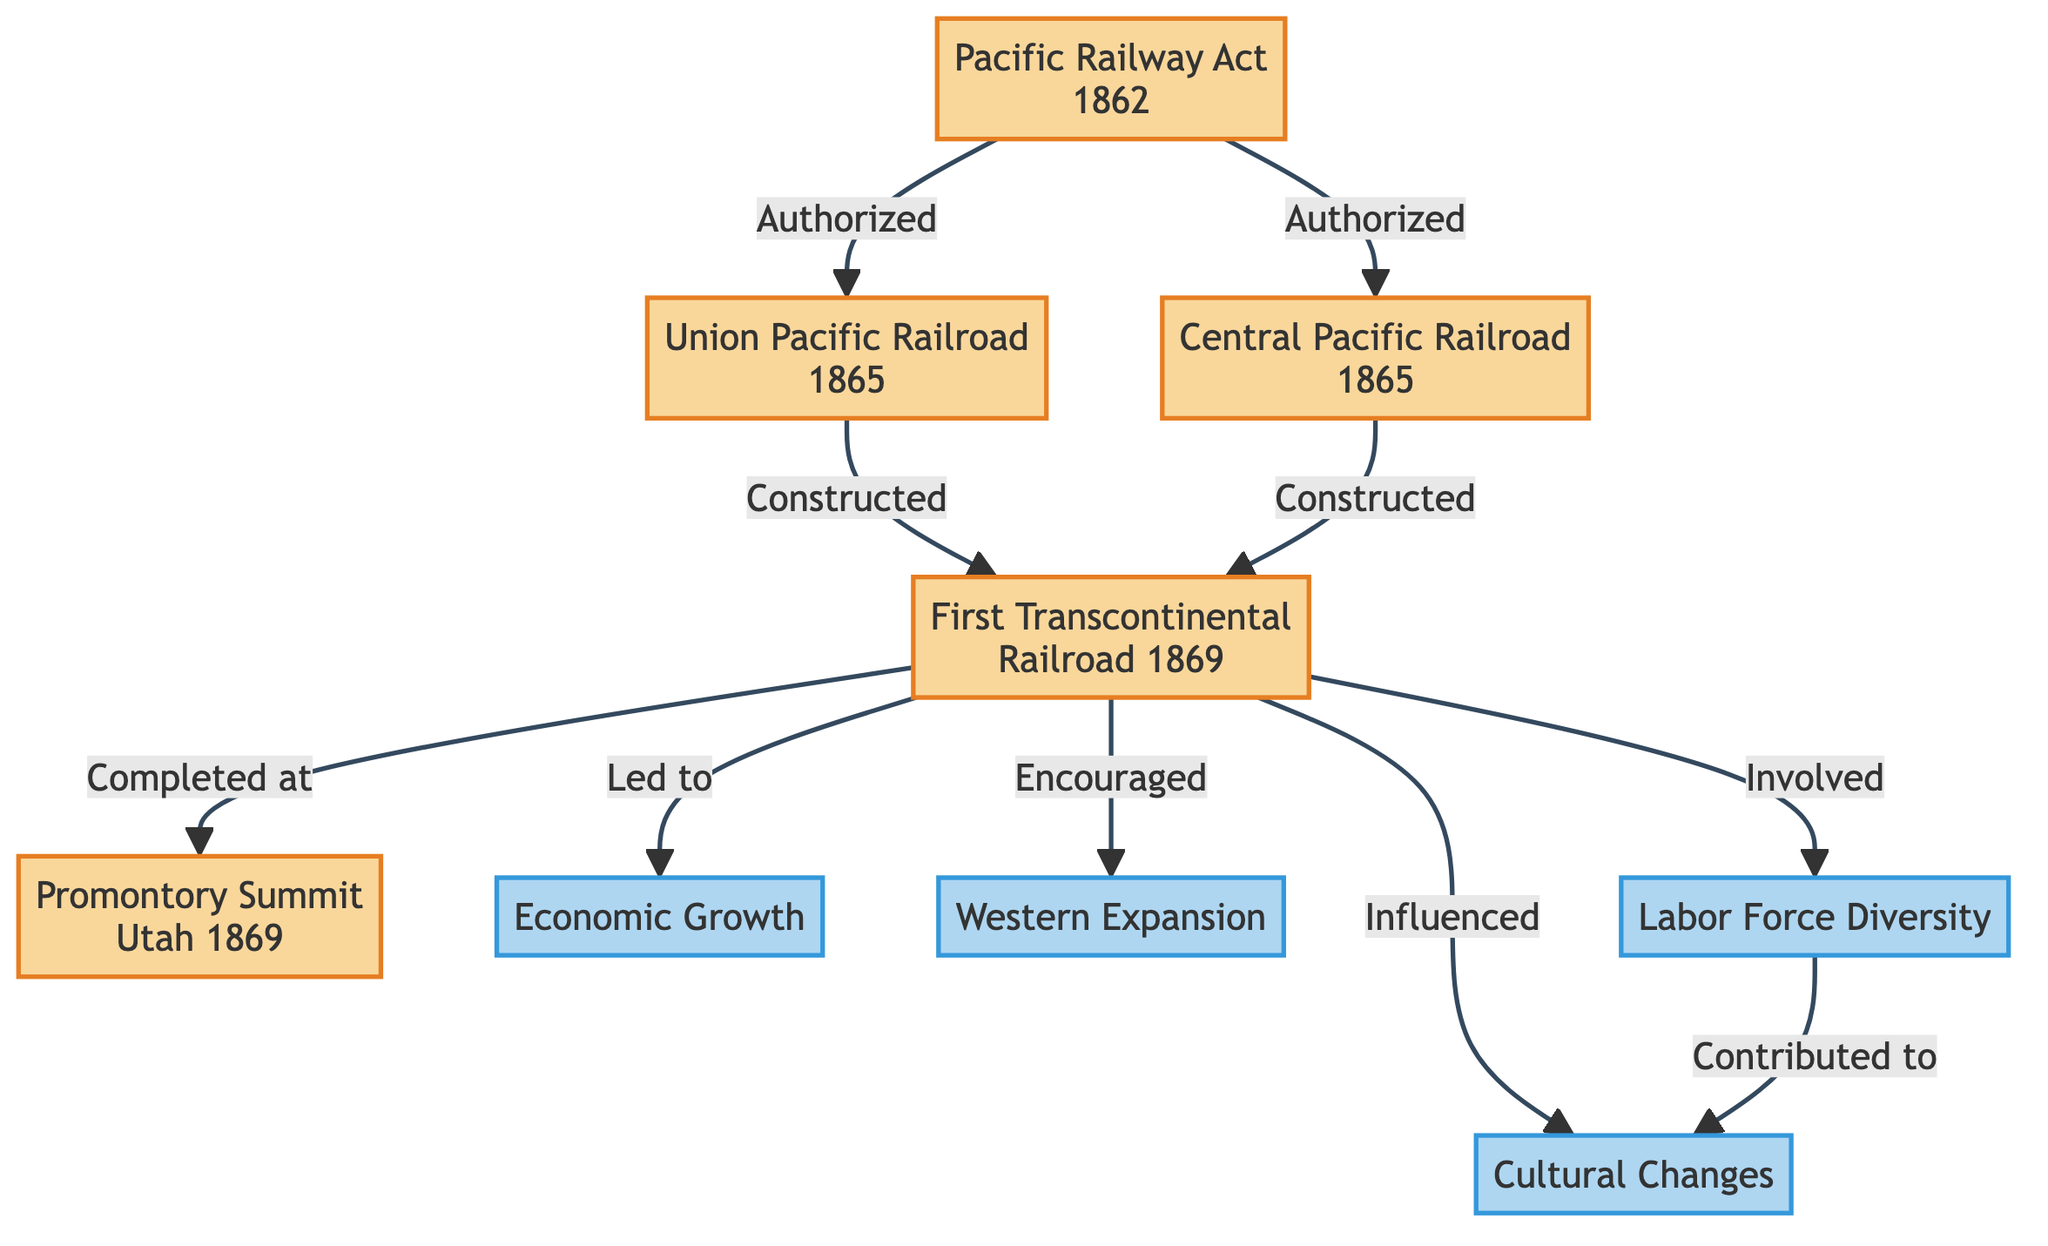What is the starting event in the diagram? The starting event is identified as the first node in the diagram, which is "Pacific Railway Act 1862." This can be seen clearly as it has no incoming edges and serves as the origin point for the construction of the railroads.
Answer: Pacific Railway Act 1862 How many impacts are listed in the diagram? The diagram features four impact nodes labeled as "Economic Growth," "Western Expansion," "Cultural Changes," and "Labor Force Diversity." Counting these individual impacts leads to the answer.
Answer: 4 Which event led to the first transcontinental railroad's completion? Tracing the flow from the event nodes, "Union Pacific Railroad 1865" and "Central Pacific Railroad 1865" both point to "First Transcontinental Railroad 1869," indicating their role in its completion. Hence, both are valid answers in context.
Answer: Union Pacific Railroad 1865 and Central Pacific Railroad 1865 What impact is directly influenced by labor force diversity? The diagram shows a directed edge leading from "Labor Force Diversity" to "Cultural Changes." This implies that labor diversity plays a direct role in shaping cultural changes, making it the answer to the question.
Answer: Cultural Changes What was completed at Promontory Summit? Following the edge in the diagram, "First Transcontinental Railroad 1869" points to "Promontory Summit Utah 1869," indicating that this location is where the first transcontinental railroad was completed.
Answer: First Transcontinental Railroad 1869 What event authorized the construction of the Union Pacific and Central Pacific railroads? In the diagram, the "Pacific Railway Act 1862" has outgoing edges that specify it authorized the construction of both "Union Pacific Railroad 1865" and "Central Pacific Railroad 1865," making it the key event in question.
Answer: Pacific Railway Act 1862 Which event does the first transcontinental railroad directly lead to? The diagram shows that the "First Transcontinental Railroad 1869" node has direct outgoing edges leading to several impacts, one of which is "Economic Growth." Thus, this event is directly linked.
Answer: Economic Growth How many edges connect events to impacts in the diagram? By tracing the connections, we can count that there are five outgoing edges from the "First Transcontinental Railroad 1869" node leading to impacts. This gives a total of five connections in the context of events linking to impacts.
Answer: 5 